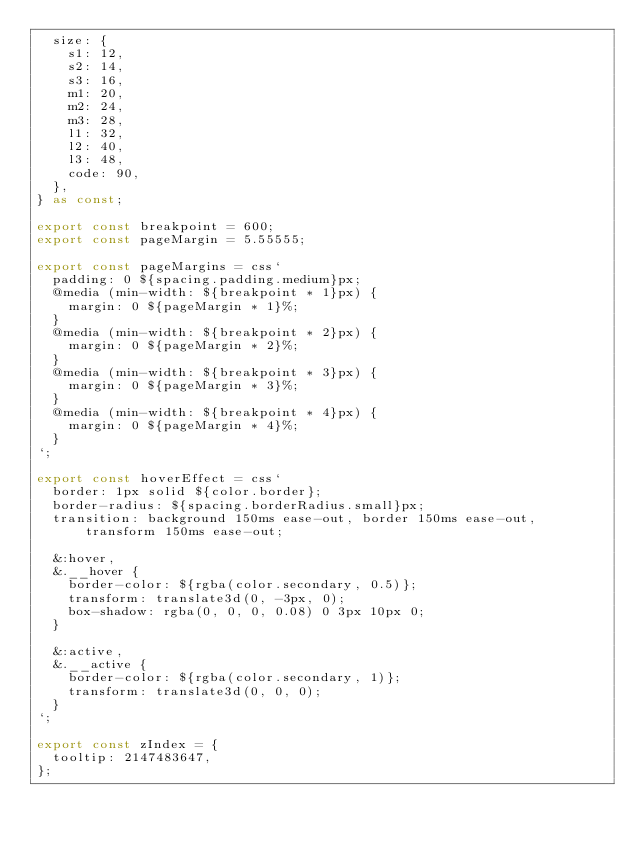<code> <loc_0><loc_0><loc_500><loc_500><_TypeScript_>  size: {
    s1: 12,
    s2: 14,
    s3: 16,
    m1: 20,
    m2: 24,
    m3: 28,
    l1: 32,
    l2: 40,
    l3: 48,
    code: 90,
  },
} as const;

export const breakpoint = 600;
export const pageMargin = 5.55555;

export const pageMargins = css`
  padding: 0 ${spacing.padding.medium}px;
  @media (min-width: ${breakpoint * 1}px) {
    margin: 0 ${pageMargin * 1}%;
  }
  @media (min-width: ${breakpoint * 2}px) {
    margin: 0 ${pageMargin * 2}%;
  }
  @media (min-width: ${breakpoint * 3}px) {
    margin: 0 ${pageMargin * 3}%;
  }
  @media (min-width: ${breakpoint * 4}px) {
    margin: 0 ${pageMargin * 4}%;
  }
`;

export const hoverEffect = css`
  border: 1px solid ${color.border};
  border-radius: ${spacing.borderRadius.small}px;
  transition: background 150ms ease-out, border 150ms ease-out, transform 150ms ease-out;

  &:hover,
  &.__hover {
    border-color: ${rgba(color.secondary, 0.5)};
    transform: translate3d(0, -3px, 0);
    box-shadow: rgba(0, 0, 0, 0.08) 0 3px 10px 0;
  }

  &:active,
  &.__active {
    border-color: ${rgba(color.secondary, 1)};
    transform: translate3d(0, 0, 0);
  }
`;

export const zIndex = {
  tooltip: 2147483647,
};
</code> 